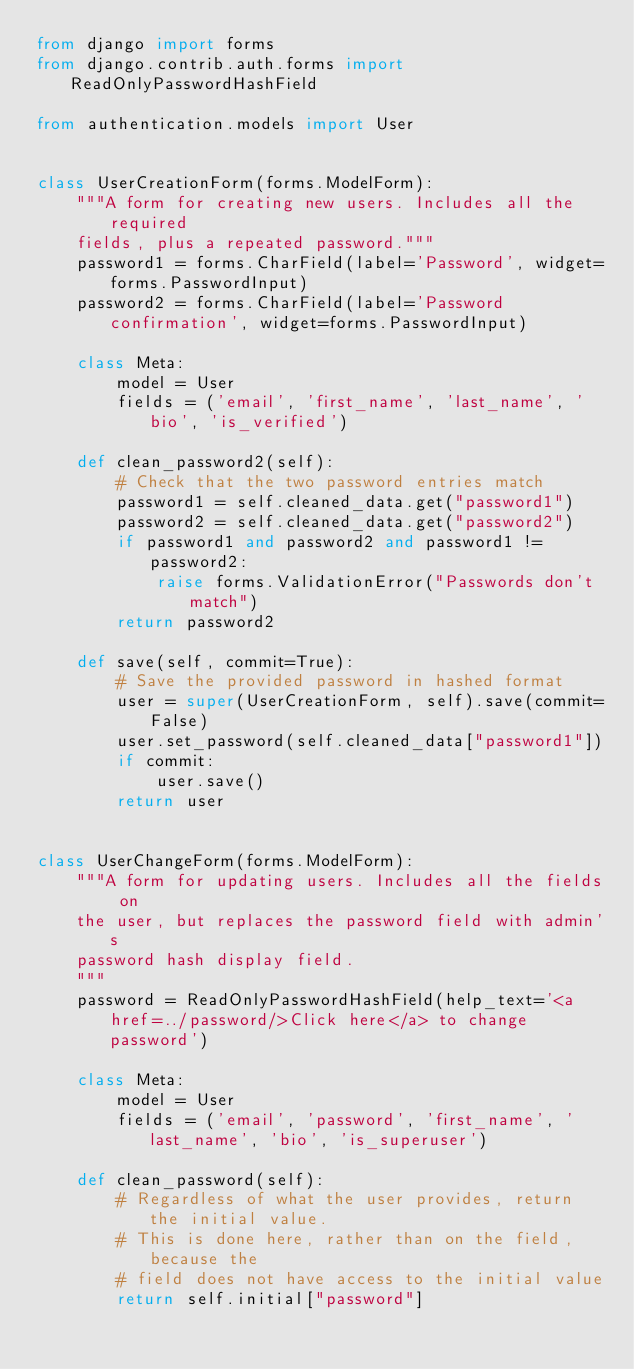Convert code to text. <code><loc_0><loc_0><loc_500><loc_500><_Python_>from django import forms
from django.contrib.auth.forms import ReadOnlyPasswordHashField

from authentication.models import User


class UserCreationForm(forms.ModelForm):
    """A form for creating new users. Includes all the required
    fields, plus a repeated password."""
    password1 = forms.CharField(label='Password', widget=forms.PasswordInput)
    password2 = forms.CharField(label='Password confirmation', widget=forms.PasswordInput)

    class Meta:
        model = User
        fields = ('email', 'first_name', 'last_name', 'bio', 'is_verified')

    def clean_password2(self):
        # Check that the two password entries match
        password1 = self.cleaned_data.get("password1")
        password2 = self.cleaned_data.get("password2")
        if password1 and password2 and password1 != password2:
            raise forms.ValidationError("Passwords don't match")
        return password2

    def save(self, commit=True):
        # Save the provided password in hashed format
        user = super(UserCreationForm, self).save(commit=False)
        user.set_password(self.cleaned_data["password1"])
        if commit:
            user.save()
        return user


class UserChangeForm(forms.ModelForm):
    """A form for updating users. Includes all the fields on
    the user, but replaces the password field with admin's
    password hash display field.
    """
    password = ReadOnlyPasswordHashField(help_text='<a href=../password/>Click here</a> to change password')

    class Meta:
        model = User
        fields = ('email', 'password', 'first_name', 'last_name', 'bio', 'is_superuser')

    def clean_password(self):
        # Regardless of what the user provides, return the initial value.
        # This is done here, rather than on the field, because the
        # field does not have access to the initial value
        return self.initial["password"]
</code> 